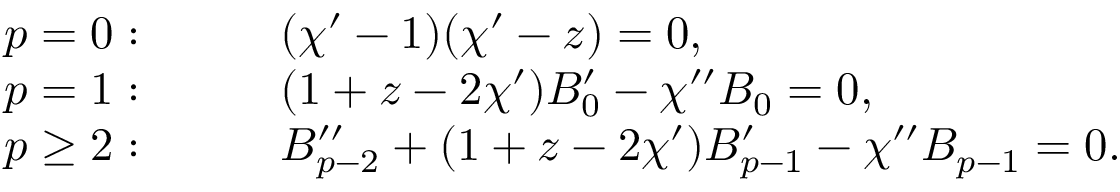<formula> <loc_0><loc_0><loc_500><loc_500>\begin{array} { r l } { p = 0 \colon } & { \quad ( \chi ^ { \prime } - 1 ) ( \chi ^ { \prime } - z ) = 0 , } \\ { p = 1 \colon } & { \quad ( 1 + z - 2 \chi ^ { \prime } ) B _ { 0 } ^ { \prime } - \chi ^ { \prime \prime } B _ { 0 } = 0 , } \\ { p \geq 2 \colon } & { \quad B _ { p - 2 } ^ { \prime \prime } + ( 1 + z - 2 \chi ^ { \prime } ) B _ { p - 1 } ^ { \prime } - \chi ^ { \prime \prime } B _ { p - 1 } = 0 . } \end{array}</formula> 